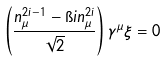Convert formula to latex. <formula><loc_0><loc_0><loc_500><loc_500>\left ( \frac { n _ { \mu } ^ { 2 i - 1 } - \i i n _ { \mu } ^ { 2 i } } { \sqrt { 2 } } \right ) \gamma ^ { \mu } \xi = 0</formula> 